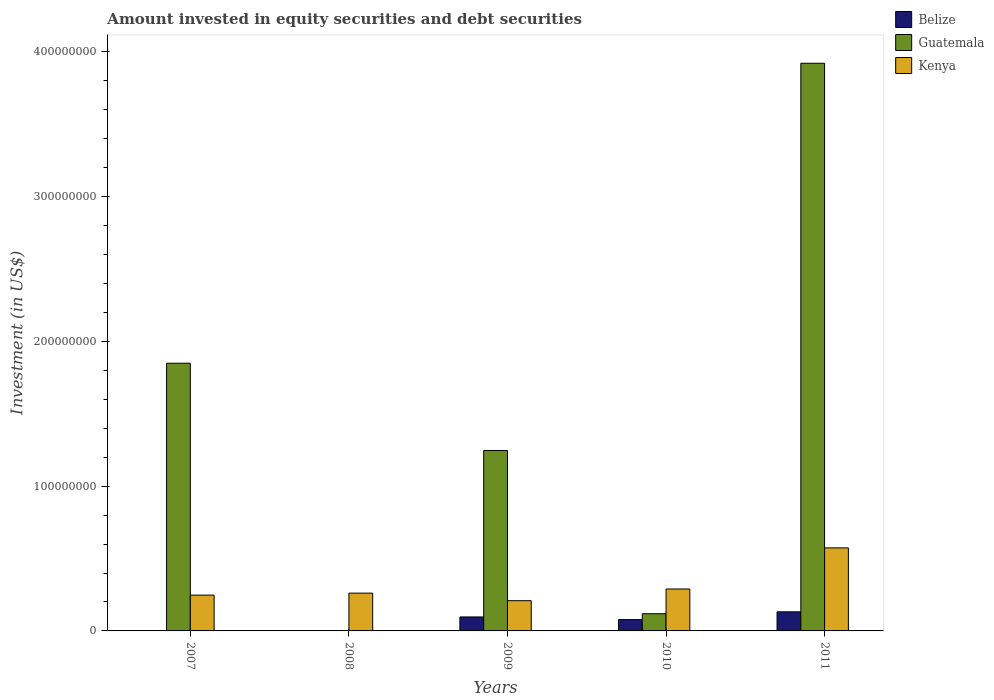Are the number of bars on each tick of the X-axis equal?
Provide a short and direct response. No. In how many cases, is the number of bars for a given year not equal to the number of legend labels?
Provide a succinct answer. 2. What is the amount invested in equity securities and debt securities in Guatemala in 2009?
Make the answer very short. 1.25e+08. Across all years, what is the maximum amount invested in equity securities and debt securities in Kenya?
Ensure brevity in your answer.  5.74e+07. Across all years, what is the minimum amount invested in equity securities and debt securities in Guatemala?
Offer a terse response. 0. What is the total amount invested in equity securities and debt securities in Kenya in the graph?
Your response must be concise. 1.58e+08. What is the difference between the amount invested in equity securities and debt securities in Kenya in 2008 and that in 2009?
Offer a terse response. 5.21e+06. What is the difference between the amount invested in equity securities and debt securities in Belize in 2010 and the amount invested in equity securities and debt securities in Guatemala in 2009?
Provide a succinct answer. -1.17e+08. What is the average amount invested in equity securities and debt securities in Guatemala per year?
Provide a succinct answer. 1.43e+08. In the year 2011, what is the difference between the amount invested in equity securities and debt securities in Guatemala and amount invested in equity securities and debt securities in Belize?
Provide a short and direct response. 3.79e+08. In how many years, is the amount invested in equity securities and debt securities in Belize greater than 280000000 US$?
Offer a very short reply. 0. What is the ratio of the amount invested in equity securities and debt securities in Belize in 2009 to that in 2011?
Give a very brief answer. 0.73. Is the amount invested in equity securities and debt securities in Guatemala in 2009 less than that in 2010?
Provide a succinct answer. No. Is the difference between the amount invested in equity securities and debt securities in Guatemala in 2010 and 2011 greater than the difference between the amount invested in equity securities and debt securities in Belize in 2010 and 2011?
Keep it short and to the point. No. What is the difference between the highest and the second highest amount invested in equity securities and debt securities in Guatemala?
Keep it short and to the point. 2.07e+08. What is the difference between the highest and the lowest amount invested in equity securities and debt securities in Guatemala?
Offer a terse response. 3.92e+08. Is the sum of the amount invested in equity securities and debt securities in Guatemala in 2009 and 2011 greater than the maximum amount invested in equity securities and debt securities in Belize across all years?
Provide a short and direct response. Yes. Is it the case that in every year, the sum of the amount invested in equity securities and debt securities in Guatemala and amount invested in equity securities and debt securities in Belize is greater than the amount invested in equity securities and debt securities in Kenya?
Offer a terse response. No. How many bars are there?
Offer a terse response. 12. What is the difference between two consecutive major ticks on the Y-axis?
Give a very brief answer. 1.00e+08. Are the values on the major ticks of Y-axis written in scientific E-notation?
Provide a succinct answer. No. Where does the legend appear in the graph?
Offer a terse response. Top right. How are the legend labels stacked?
Your answer should be compact. Vertical. What is the title of the graph?
Provide a succinct answer. Amount invested in equity securities and debt securities. Does "Tajikistan" appear as one of the legend labels in the graph?
Ensure brevity in your answer.  No. What is the label or title of the X-axis?
Offer a terse response. Years. What is the label or title of the Y-axis?
Make the answer very short. Investment (in US$). What is the Investment (in US$) in Belize in 2007?
Your response must be concise. 0. What is the Investment (in US$) in Guatemala in 2007?
Your response must be concise. 1.85e+08. What is the Investment (in US$) of Kenya in 2007?
Your answer should be very brief. 2.47e+07. What is the Investment (in US$) in Guatemala in 2008?
Make the answer very short. 0. What is the Investment (in US$) of Kenya in 2008?
Make the answer very short. 2.61e+07. What is the Investment (in US$) in Belize in 2009?
Give a very brief answer. 9.65e+06. What is the Investment (in US$) in Guatemala in 2009?
Your answer should be very brief. 1.25e+08. What is the Investment (in US$) of Kenya in 2009?
Offer a very short reply. 2.09e+07. What is the Investment (in US$) of Belize in 2010?
Make the answer very short. 7.81e+06. What is the Investment (in US$) in Guatemala in 2010?
Offer a very short reply. 1.19e+07. What is the Investment (in US$) in Kenya in 2010?
Offer a terse response. 2.90e+07. What is the Investment (in US$) of Belize in 2011?
Offer a very short reply. 1.32e+07. What is the Investment (in US$) in Guatemala in 2011?
Make the answer very short. 3.92e+08. What is the Investment (in US$) of Kenya in 2011?
Keep it short and to the point. 5.74e+07. Across all years, what is the maximum Investment (in US$) in Belize?
Make the answer very short. 1.32e+07. Across all years, what is the maximum Investment (in US$) of Guatemala?
Make the answer very short. 3.92e+08. Across all years, what is the maximum Investment (in US$) in Kenya?
Give a very brief answer. 5.74e+07. Across all years, what is the minimum Investment (in US$) in Belize?
Offer a terse response. 0. Across all years, what is the minimum Investment (in US$) of Kenya?
Offer a very short reply. 2.09e+07. What is the total Investment (in US$) of Belize in the graph?
Ensure brevity in your answer.  3.07e+07. What is the total Investment (in US$) in Guatemala in the graph?
Offer a very short reply. 7.13e+08. What is the total Investment (in US$) of Kenya in the graph?
Your answer should be very brief. 1.58e+08. What is the difference between the Investment (in US$) of Kenya in 2007 and that in 2008?
Offer a terse response. -1.37e+06. What is the difference between the Investment (in US$) of Guatemala in 2007 and that in 2009?
Keep it short and to the point. 6.03e+07. What is the difference between the Investment (in US$) in Kenya in 2007 and that in 2009?
Keep it short and to the point. 3.84e+06. What is the difference between the Investment (in US$) of Guatemala in 2007 and that in 2010?
Your response must be concise. 1.73e+08. What is the difference between the Investment (in US$) of Kenya in 2007 and that in 2010?
Provide a succinct answer. -4.23e+06. What is the difference between the Investment (in US$) of Guatemala in 2007 and that in 2011?
Provide a succinct answer. -2.07e+08. What is the difference between the Investment (in US$) of Kenya in 2007 and that in 2011?
Your response must be concise. -3.26e+07. What is the difference between the Investment (in US$) of Kenya in 2008 and that in 2009?
Keep it short and to the point. 5.21e+06. What is the difference between the Investment (in US$) of Kenya in 2008 and that in 2010?
Provide a short and direct response. -2.86e+06. What is the difference between the Investment (in US$) in Kenya in 2008 and that in 2011?
Make the answer very short. -3.13e+07. What is the difference between the Investment (in US$) of Belize in 2009 and that in 2010?
Your response must be concise. 1.84e+06. What is the difference between the Investment (in US$) in Guatemala in 2009 and that in 2010?
Provide a succinct answer. 1.13e+08. What is the difference between the Investment (in US$) of Kenya in 2009 and that in 2010?
Offer a terse response. -8.07e+06. What is the difference between the Investment (in US$) of Belize in 2009 and that in 2011?
Your response must be concise. -3.54e+06. What is the difference between the Investment (in US$) in Guatemala in 2009 and that in 2011?
Make the answer very short. -2.67e+08. What is the difference between the Investment (in US$) of Kenya in 2009 and that in 2011?
Offer a terse response. -3.65e+07. What is the difference between the Investment (in US$) of Belize in 2010 and that in 2011?
Offer a terse response. -5.38e+06. What is the difference between the Investment (in US$) in Guatemala in 2010 and that in 2011?
Provide a short and direct response. -3.80e+08. What is the difference between the Investment (in US$) of Kenya in 2010 and that in 2011?
Your answer should be compact. -2.84e+07. What is the difference between the Investment (in US$) of Guatemala in 2007 and the Investment (in US$) of Kenya in 2008?
Keep it short and to the point. 1.59e+08. What is the difference between the Investment (in US$) of Guatemala in 2007 and the Investment (in US$) of Kenya in 2009?
Provide a succinct answer. 1.64e+08. What is the difference between the Investment (in US$) in Guatemala in 2007 and the Investment (in US$) in Kenya in 2010?
Make the answer very short. 1.56e+08. What is the difference between the Investment (in US$) of Guatemala in 2007 and the Investment (in US$) of Kenya in 2011?
Give a very brief answer. 1.28e+08. What is the difference between the Investment (in US$) of Belize in 2009 and the Investment (in US$) of Guatemala in 2010?
Offer a very short reply. -2.22e+06. What is the difference between the Investment (in US$) in Belize in 2009 and the Investment (in US$) in Kenya in 2010?
Your answer should be compact. -1.93e+07. What is the difference between the Investment (in US$) in Guatemala in 2009 and the Investment (in US$) in Kenya in 2010?
Keep it short and to the point. 9.57e+07. What is the difference between the Investment (in US$) of Belize in 2009 and the Investment (in US$) of Guatemala in 2011?
Provide a succinct answer. -3.82e+08. What is the difference between the Investment (in US$) in Belize in 2009 and the Investment (in US$) in Kenya in 2011?
Ensure brevity in your answer.  -4.77e+07. What is the difference between the Investment (in US$) in Guatemala in 2009 and the Investment (in US$) in Kenya in 2011?
Offer a very short reply. 6.73e+07. What is the difference between the Investment (in US$) in Belize in 2010 and the Investment (in US$) in Guatemala in 2011?
Give a very brief answer. -3.84e+08. What is the difference between the Investment (in US$) of Belize in 2010 and the Investment (in US$) of Kenya in 2011?
Your response must be concise. -4.95e+07. What is the difference between the Investment (in US$) of Guatemala in 2010 and the Investment (in US$) of Kenya in 2011?
Offer a very short reply. -4.55e+07. What is the average Investment (in US$) in Belize per year?
Offer a terse response. 6.13e+06. What is the average Investment (in US$) of Guatemala per year?
Keep it short and to the point. 1.43e+08. What is the average Investment (in US$) of Kenya per year?
Keep it short and to the point. 3.16e+07. In the year 2007, what is the difference between the Investment (in US$) in Guatemala and Investment (in US$) in Kenya?
Keep it short and to the point. 1.60e+08. In the year 2009, what is the difference between the Investment (in US$) of Belize and Investment (in US$) of Guatemala?
Your response must be concise. -1.15e+08. In the year 2009, what is the difference between the Investment (in US$) of Belize and Investment (in US$) of Kenya?
Ensure brevity in your answer.  -1.12e+07. In the year 2009, what is the difference between the Investment (in US$) of Guatemala and Investment (in US$) of Kenya?
Offer a very short reply. 1.04e+08. In the year 2010, what is the difference between the Investment (in US$) in Belize and Investment (in US$) in Guatemala?
Keep it short and to the point. -4.06e+06. In the year 2010, what is the difference between the Investment (in US$) in Belize and Investment (in US$) in Kenya?
Your answer should be compact. -2.11e+07. In the year 2010, what is the difference between the Investment (in US$) of Guatemala and Investment (in US$) of Kenya?
Your answer should be compact. -1.71e+07. In the year 2011, what is the difference between the Investment (in US$) of Belize and Investment (in US$) of Guatemala?
Give a very brief answer. -3.79e+08. In the year 2011, what is the difference between the Investment (in US$) of Belize and Investment (in US$) of Kenya?
Offer a terse response. -4.42e+07. In the year 2011, what is the difference between the Investment (in US$) in Guatemala and Investment (in US$) in Kenya?
Your answer should be very brief. 3.35e+08. What is the ratio of the Investment (in US$) in Kenya in 2007 to that in 2008?
Provide a short and direct response. 0.95. What is the ratio of the Investment (in US$) in Guatemala in 2007 to that in 2009?
Your response must be concise. 1.48. What is the ratio of the Investment (in US$) in Kenya in 2007 to that in 2009?
Your answer should be compact. 1.18. What is the ratio of the Investment (in US$) of Guatemala in 2007 to that in 2010?
Make the answer very short. 15.57. What is the ratio of the Investment (in US$) in Kenya in 2007 to that in 2010?
Give a very brief answer. 0.85. What is the ratio of the Investment (in US$) of Guatemala in 2007 to that in 2011?
Give a very brief answer. 0.47. What is the ratio of the Investment (in US$) in Kenya in 2007 to that in 2011?
Provide a short and direct response. 0.43. What is the ratio of the Investment (in US$) of Kenya in 2008 to that in 2009?
Make the answer very short. 1.25. What is the ratio of the Investment (in US$) in Kenya in 2008 to that in 2010?
Make the answer very short. 0.9. What is the ratio of the Investment (in US$) of Kenya in 2008 to that in 2011?
Make the answer very short. 0.46. What is the ratio of the Investment (in US$) of Belize in 2009 to that in 2010?
Offer a terse response. 1.24. What is the ratio of the Investment (in US$) in Guatemala in 2009 to that in 2010?
Your answer should be compact. 10.49. What is the ratio of the Investment (in US$) of Kenya in 2009 to that in 2010?
Your answer should be compact. 0.72. What is the ratio of the Investment (in US$) of Belize in 2009 to that in 2011?
Ensure brevity in your answer.  0.73. What is the ratio of the Investment (in US$) in Guatemala in 2009 to that in 2011?
Provide a succinct answer. 0.32. What is the ratio of the Investment (in US$) in Kenya in 2009 to that in 2011?
Keep it short and to the point. 0.36. What is the ratio of the Investment (in US$) in Belize in 2010 to that in 2011?
Your response must be concise. 0.59. What is the ratio of the Investment (in US$) in Guatemala in 2010 to that in 2011?
Ensure brevity in your answer.  0.03. What is the ratio of the Investment (in US$) in Kenya in 2010 to that in 2011?
Provide a succinct answer. 0.5. What is the difference between the highest and the second highest Investment (in US$) in Belize?
Ensure brevity in your answer.  3.54e+06. What is the difference between the highest and the second highest Investment (in US$) in Guatemala?
Your answer should be very brief. 2.07e+08. What is the difference between the highest and the second highest Investment (in US$) in Kenya?
Ensure brevity in your answer.  2.84e+07. What is the difference between the highest and the lowest Investment (in US$) of Belize?
Your answer should be compact. 1.32e+07. What is the difference between the highest and the lowest Investment (in US$) in Guatemala?
Your answer should be very brief. 3.92e+08. What is the difference between the highest and the lowest Investment (in US$) in Kenya?
Your response must be concise. 3.65e+07. 